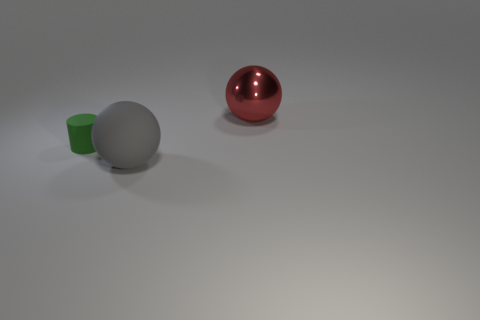Is there any other thing that has the same material as the red sphere?
Offer a terse response. No. Do the big object right of the large gray rubber sphere and the large thing in front of the red object have the same shape?
Make the answer very short. Yes. What is the size of the matte thing that is left of the large sphere that is in front of the large sphere right of the gray thing?
Your answer should be very brief. Small. What size is the rubber object that is in front of the green rubber thing?
Offer a very short reply. Large. What is the sphere that is behind the tiny green matte cylinder made of?
Your answer should be compact. Metal. What number of green objects are either rubber spheres or cylinders?
Keep it short and to the point. 1. Does the tiny green cylinder have the same material as the sphere that is in front of the tiny cylinder?
Your answer should be very brief. Yes. Is the number of matte things right of the green cylinder the same as the number of tiny matte things to the left of the red metallic object?
Ensure brevity in your answer.  Yes. Is the size of the gray object the same as the object that is behind the green cylinder?
Your answer should be compact. Yes. Is the number of big spheres that are behind the gray ball greater than the number of large metallic cubes?
Your answer should be compact. Yes. 